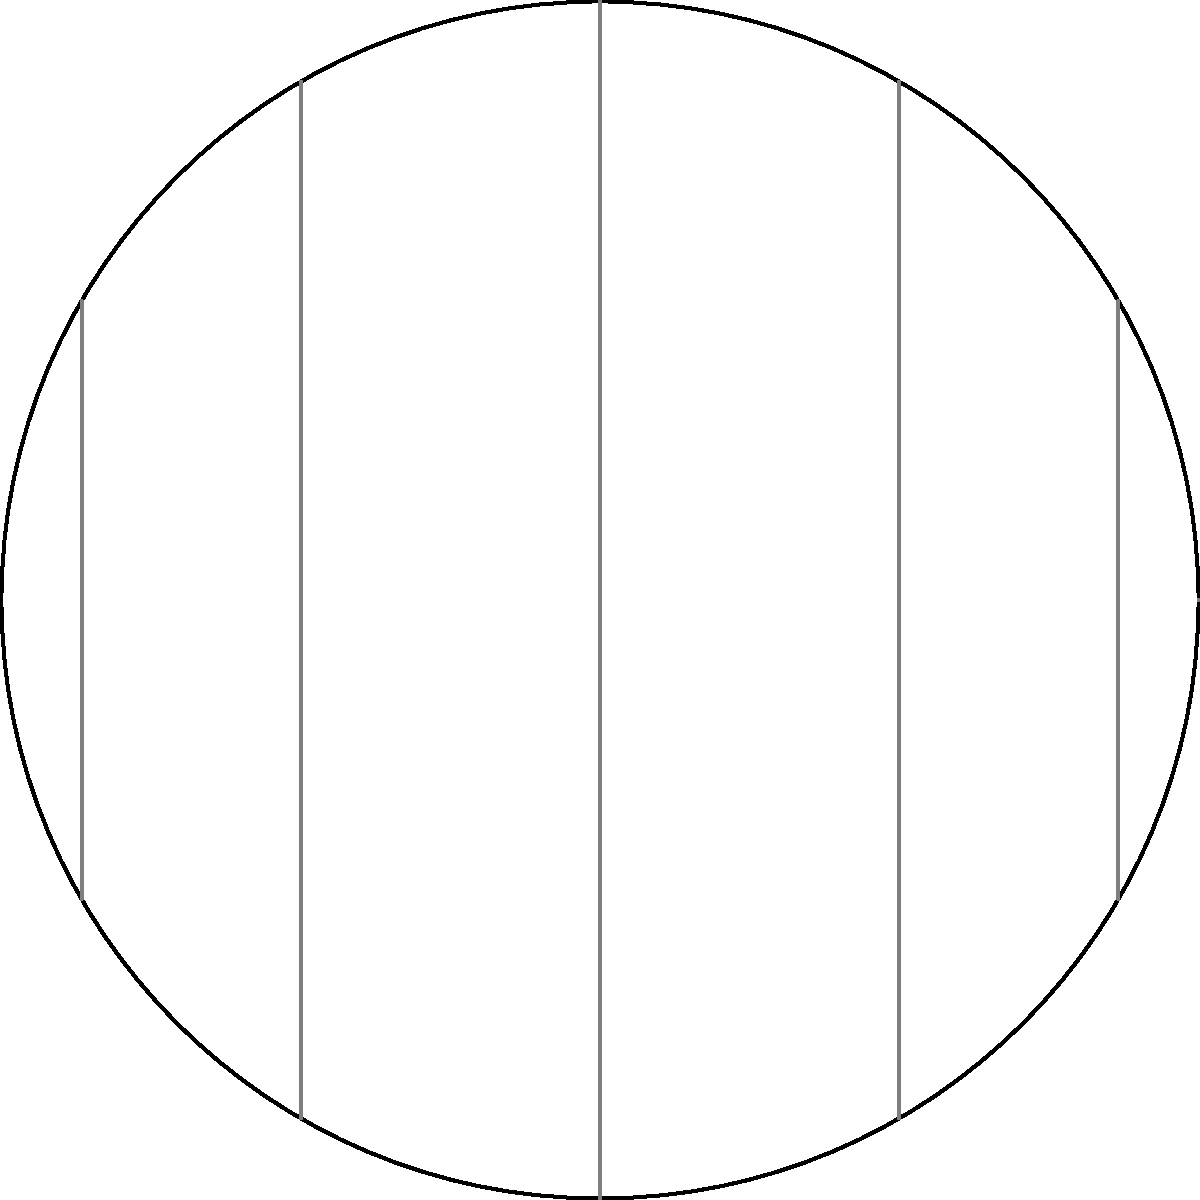Consider the non-Euclidean geometry of time zones on a globe. If a geographer is traveling along the 45°N parallel from 0° longitude (Prime Meridian) to 180° longitude (International Date Line), how many standard time zone boundaries will they cross, assuming each time zone is ideally 15° of longitude wide? To solve this problem, we need to follow these steps:

1. Understand the relationship between longitude and time zones:
   - Each time zone is ideally 15° of longitude wide.
   - This is because the Earth rotates 360° in 24 hours, so 15° = 360° / 24.

2. Calculate the total longitude covered:
   - The journey starts at 0° and ends at 180°.
   - Total longitude covered = 180° - 0° = 180°

3. Calculate the number of time zone boundaries crossed:
   - Number of time zones = Total longitude / Width of each time zone
   - Number of time zones = 180° / 15° = 12

4. Consider the number of boundaries:
   - The number of boundaries crossed is one less than the number of time zones entered.
   - Number of boundaries = 12 - 1 = 11

5. Account for the non-Euclidean nature of the globe:
   - On a flat map, this would be the final answer.
   - However, on a globe, the 180° longitude line (International Date Line) is also a time zone boundary.
   - Therefore, we need to add one more boundary to our count.

6. Final calculation:
   - Total number of time zone boundaries crossed = 11 + 1 = 12

It's important to note that in reality, time zone boundaries often deviate from the ideal 15° lines due to political and practical considerations. However, for the purposes of this idealized geometric problem on a globe, we consider the standard model.
Answer: 12 time zone boundaries 